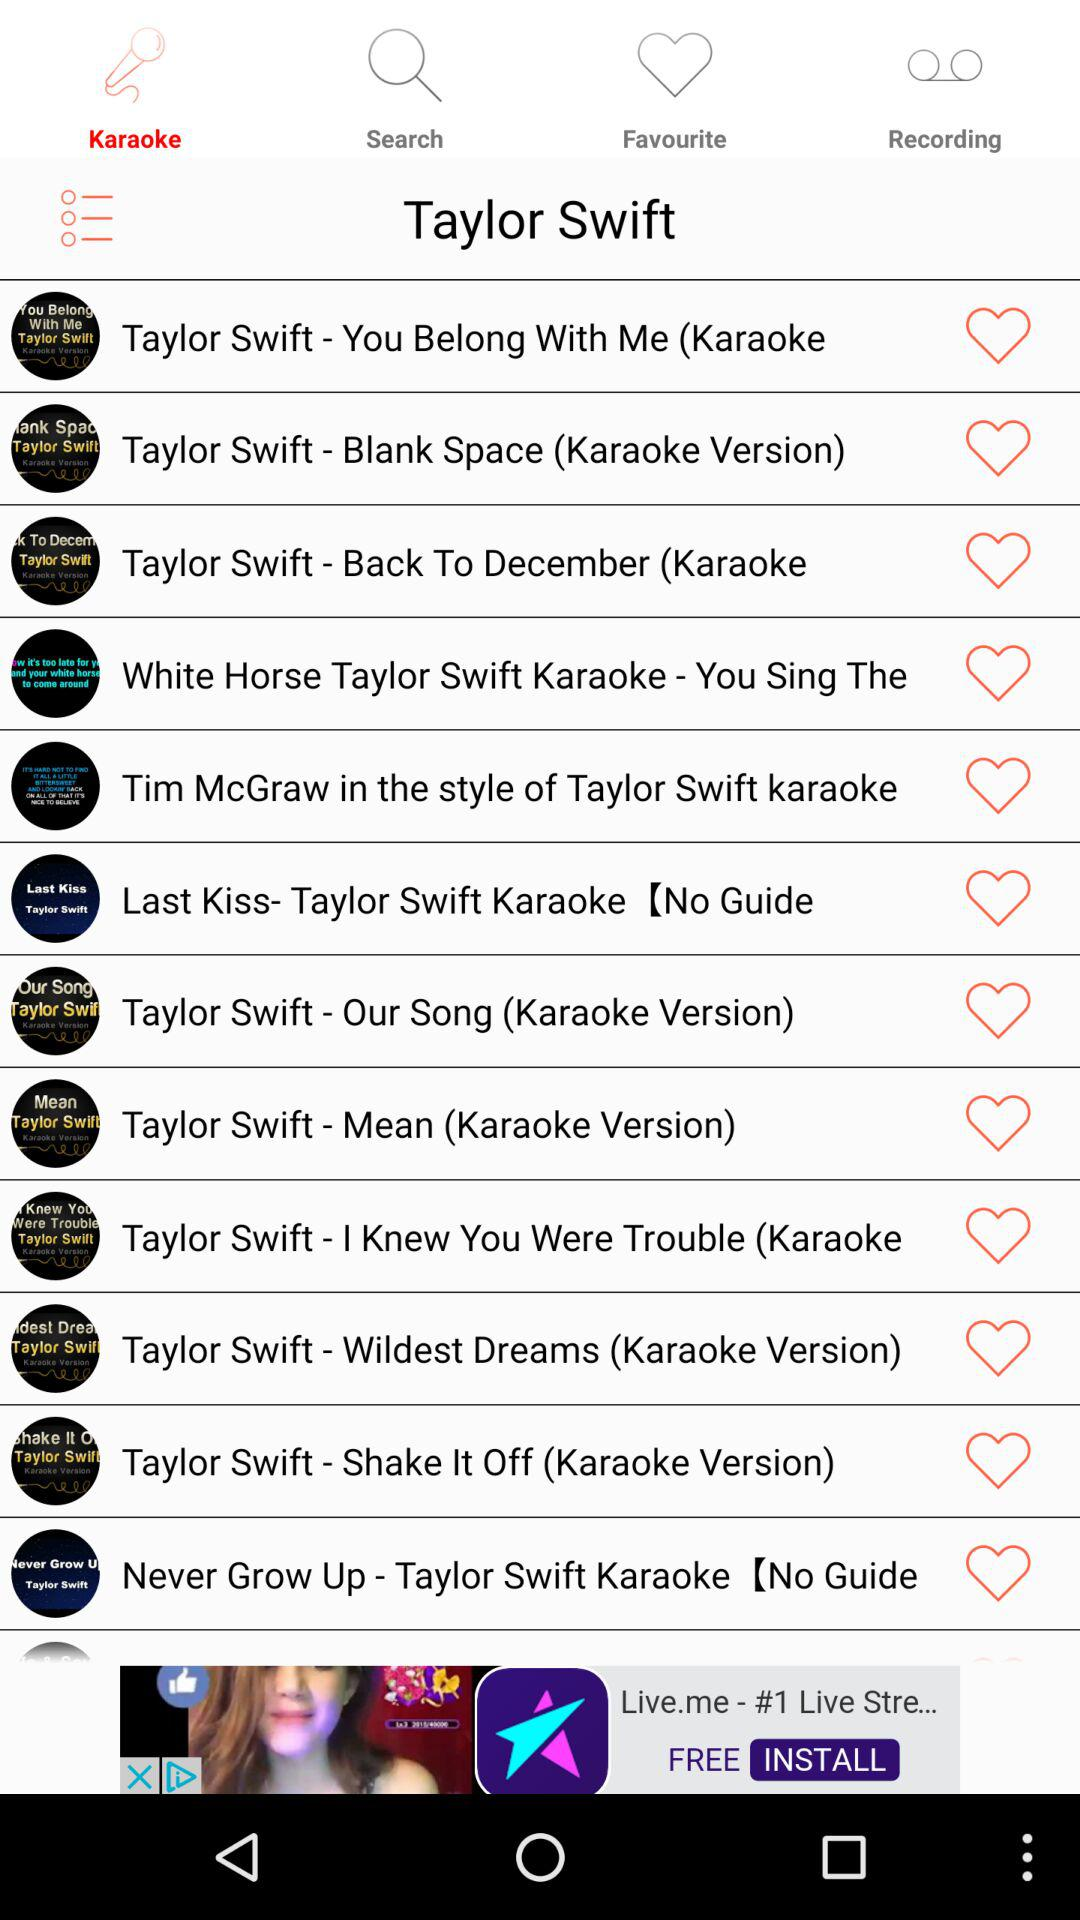Which option is selected? The selected option is "Karaoke". 